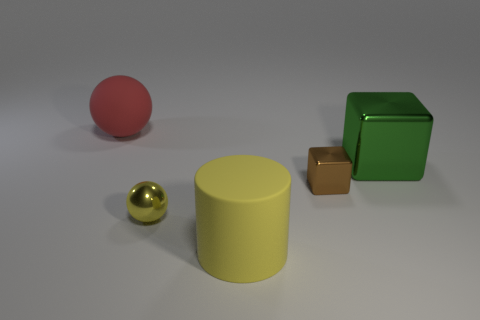There is a big thing that is left of the green thing and in front of the matte sphere; what material is it made of?
Your answer should be compact. Rubber. There is a tiny thing on the right side of the tiny yellow metallic sphere; what is its color?
Provide a succinct answer. Brown. Are there more green metal cubes that are to the left of the small metallic block than green blocks?
Provide a short and direct response. No. What number of other things are the same size as the cylinder?
Provide a short and direct response. 2. What number of big yellow matte cylinders are to the left of the big yellow cylinder?
Make the answer very short. 0. Are there the same number of green shiny things that are behind the large red sphere and big cubes that are to the left of the yellow matte object?
Provide a short and direct response. Yes. The other metal object that is the same shape as the tiny brown thing is what size?
Your answer should be compact. Large. What is the shape of the metallic thing in front of the small brown cube?
Your answer should be very brief. Sphere. Do the large thing behind the large green metallic cube and the ball on the right side of the large red rubber thing have the same material?
Your response must be concise. No. What shape is the big yellow rubber object?
Ensure brevity in your answer.  Cylinder. 